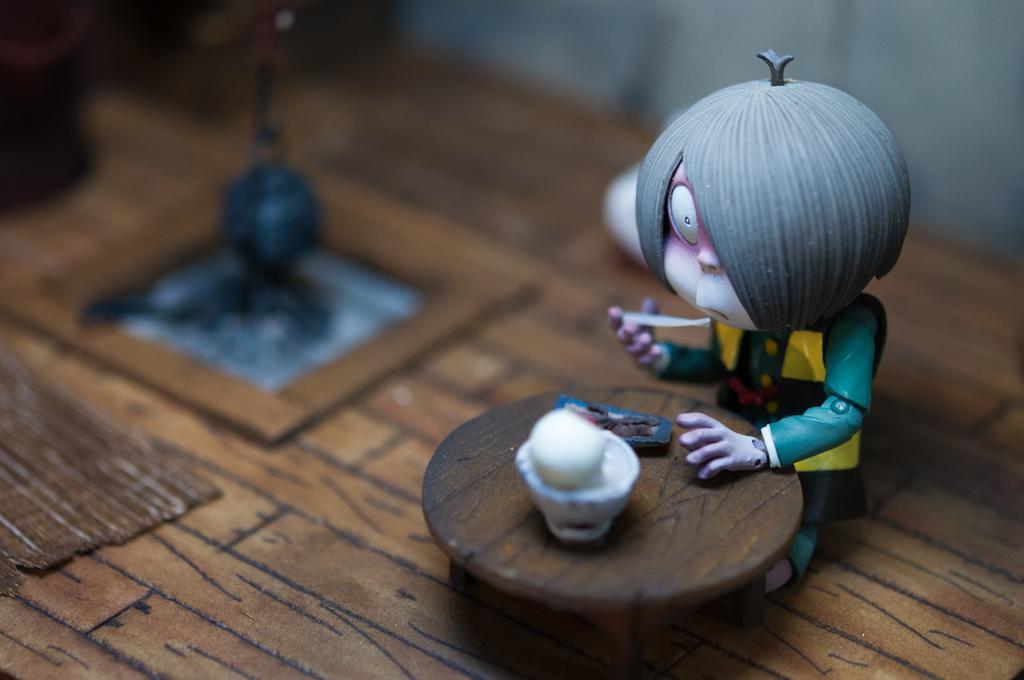How would you summarize this image in a sentence or two? In this image I can see a doll and a small table. 